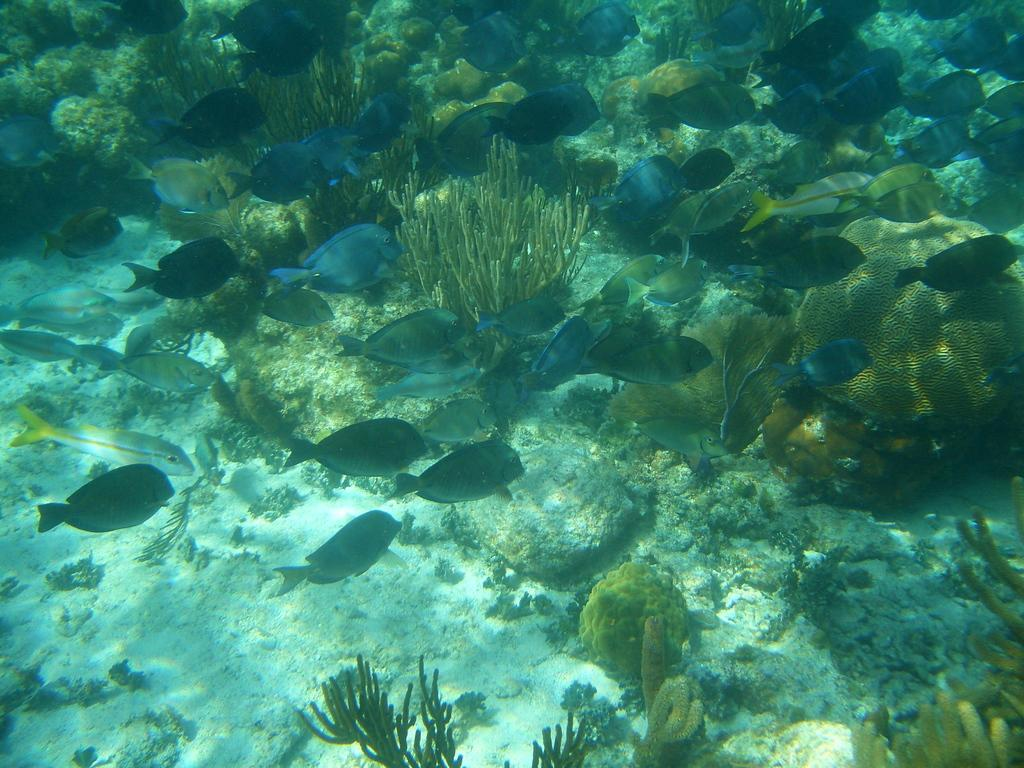What type of animals can be seen in the image? There are fishes in the image. What other objects or features can be seen in the image? There are corals in the image. What is the environment in which the fishes and corals are located? The fishes and corals are in water. What type of discussion is taking place between the fishes in the image? There is no discussion taking place between the fishes in the image, as they are animals and do not engage in discussions. 